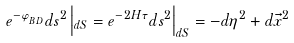<formula> <loc_0><loc_0><loc_500><loc_500>e ^ { - \varphi _ { _ { B D } } } d s ^ { 2 } \left | _ { d S } = e ^ { - 2 H \tau } d s ^ { 2 } \right | _ { d S } = - d \eta ^ { 2 } + d \vec { x } ^ { 2 } \,</formula> 